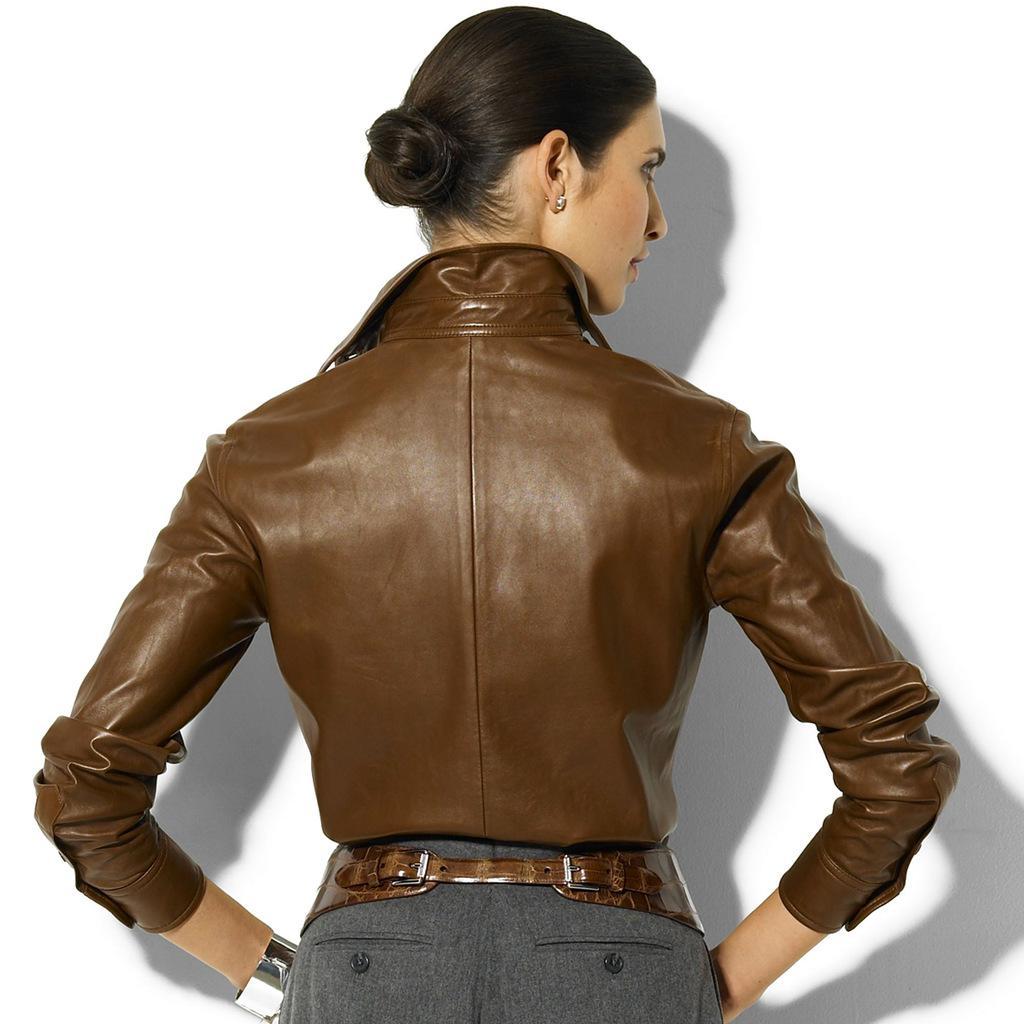Please provide a concise description of this image. In this picture there is a woman standing wearing a brown jacket. In the background it is well. 